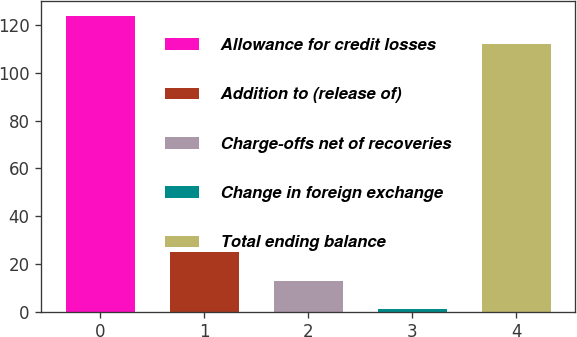Convert chart. <chart><loc_0><loc_0><loc_500><loc_500><bar_chart><fcel>Allowance for credit losses<fcel>Addition to (release of)<fcel>Charge-offs net of recoveries<fcel>Change in foreign exchange<fcel>Total ending balance<nl><fcel>123.77<fcel>24.82<fcel>13.05<fcel>1.28<fcel>112<nl></chart> 